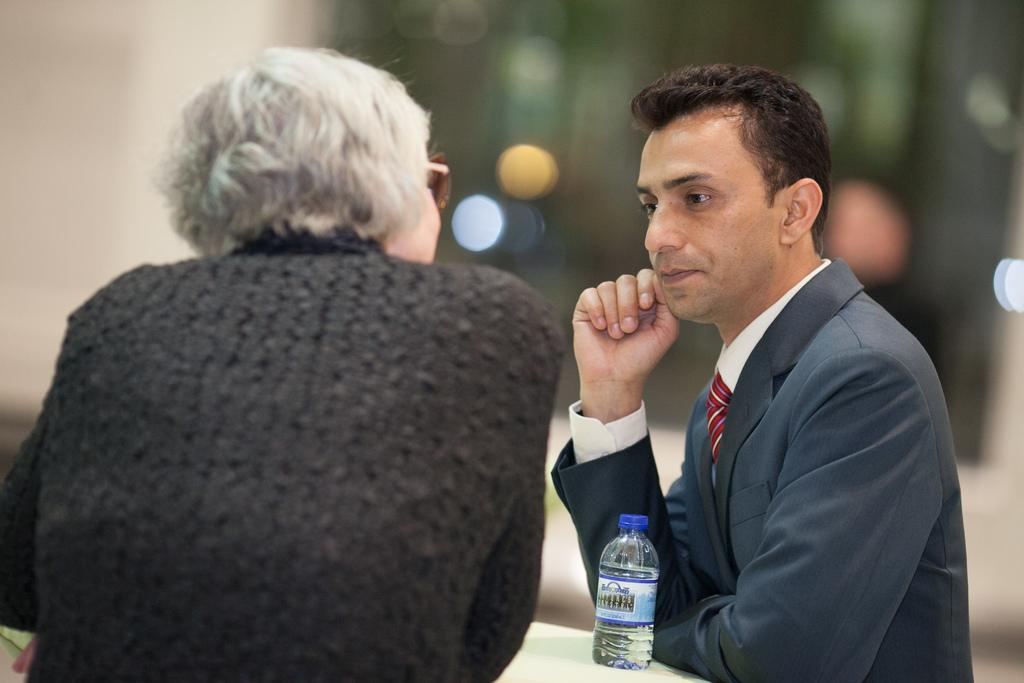How many people are in the image? There are persons in the image, but the exact number cannot be determined from the provided facts. What object can be seen on a table in the image? There is a bottle on a table in the image. Can you describe the background of the image? The background of the image is blurry. What type of flowers can be seen growing on the trail in the image? There is no trail or flowers present in the image; it only features persons and a bottle on a table. 